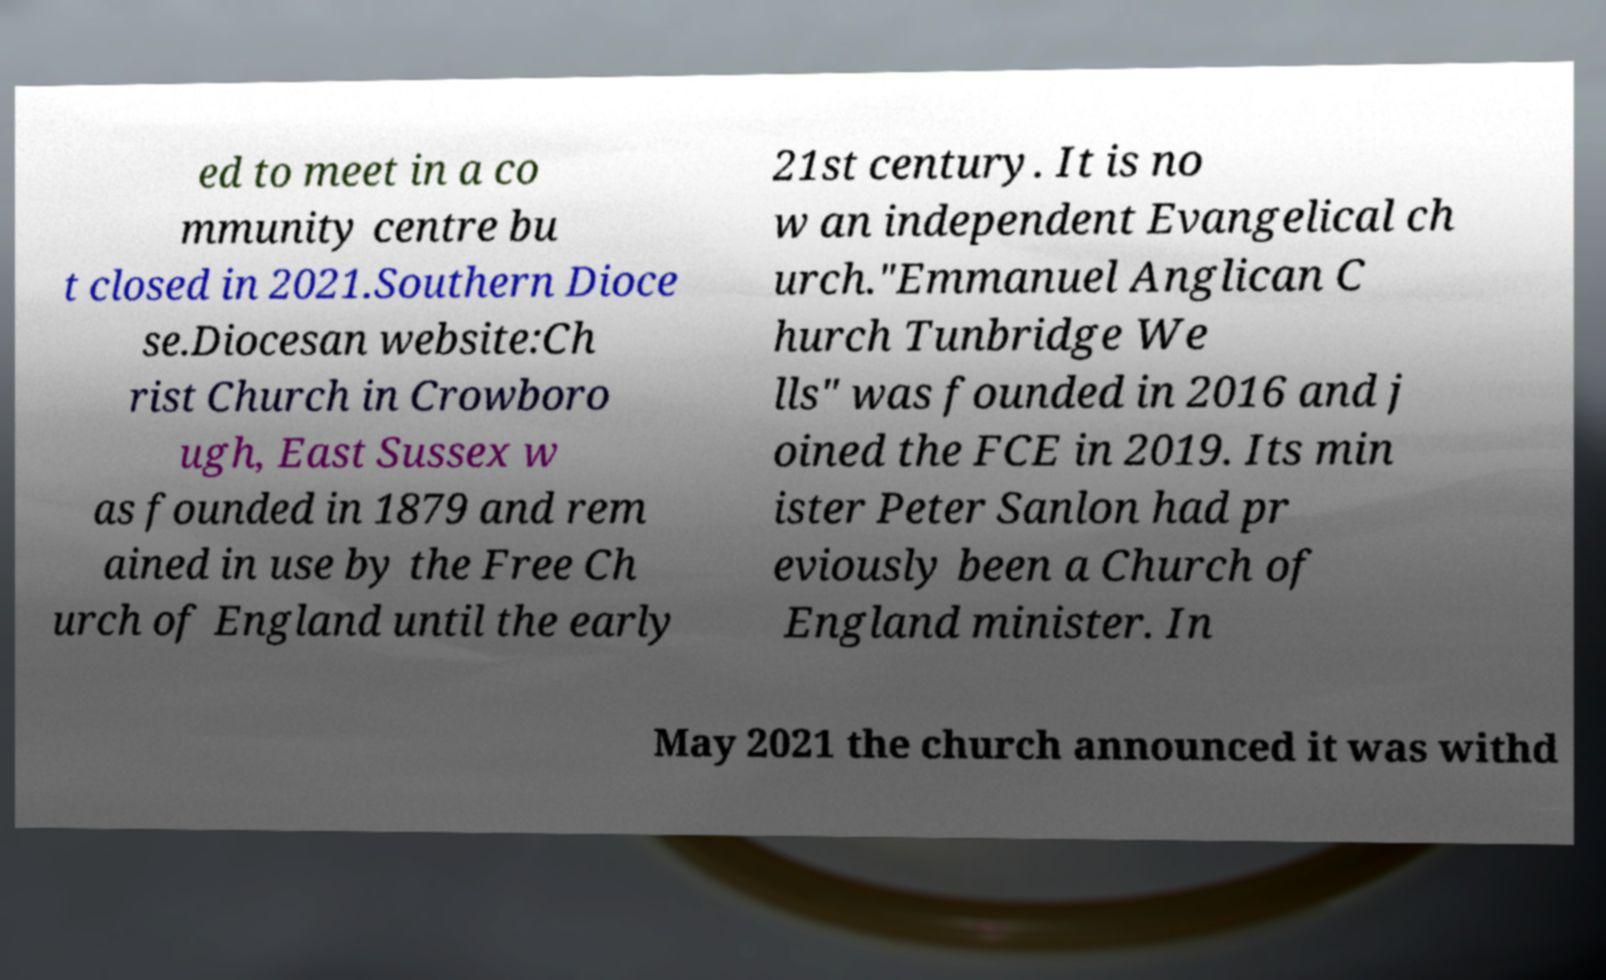Can you accurately transcribe the text from the provided image for me? ed to meet in a co mmunity centre bu t closed in 2021.Southern Dioce se.Diocesan website:Ch rist Church in Crowboro ugh, East Sussex w as founded in 1879 and rem ained in use by the Free Ch urch of England until the early 21st century. It is no w an independent Evangelical ch urch."Emmanuel Anglican C hurch Tunbridge We lls" was founded in 2016 and j oined the FCE in 2019. Its min ister Peter Sanlon had pr eviously been a Church of England minister. In May 2021 the church announced it was withd 